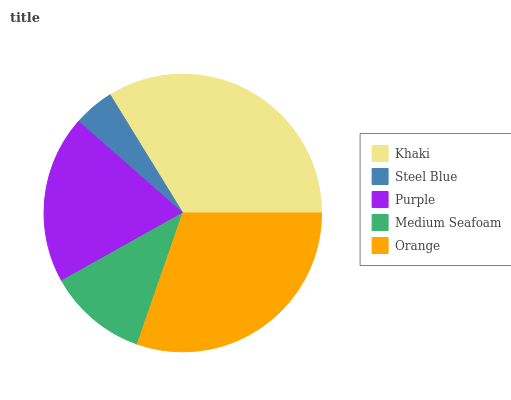Is Steel Blue the minimum?
Answer yes or no. Yes. Is Khaki the maximum?
Answer yes or no. Yes. Is Purple the minimum?
Answer yes or no. No. Is Purple the maximum?
Answer yes or no. No. Is Purple greater than Steel Blue?
Answer yes or no. Yes. Is Steel Blue less than Purple?
Answer yes or no. Yes. Is Steel Blue greater than Purple?
Answer yes or no. No. Is Purple less than Steel Blue?
Answer yes or no. No. Is Purple the high median?
Answer yes or no. Yes. Is Purple the low median?
Answer yes or no. Yes. Is Medium Seafoam the high median?
Answer yes or no. No. Is Steel Blue the low median?
Answer yes or no. No. 